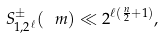Convert formula to latex. <formula><loc_0><loc_0><loc_500><loc_500>S ^ { \pm } _ { 1 , 2 ^ { \ell } } ( \ m ) \ll 2 ^ { \ell ( \frac { n } { 2 } + 1 ) } ,</formula> 